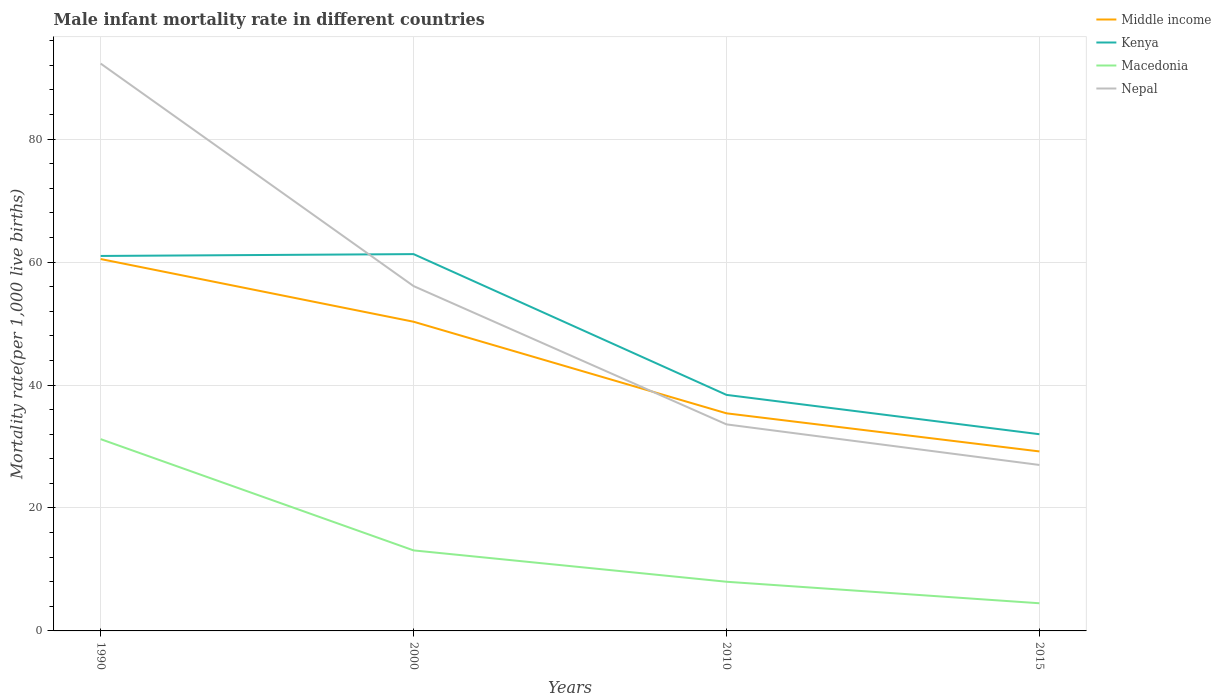In which year was the male infant mortality rate in Middle income maximum?
Provide a short and direct response. 2015. What is the total male infant mortality rate in Middle income in the graph?
Offer a very short reply. 10.2. What is the difference between the highest and the second highest male infant mortality rate in Middle income?
Your answer should be very brief. 31.3. What is the difference between the highest and the lowest male infant mortality rate in Nepal?
Your response must be concise. 2. Is the male infant mortality rate in Kenya strictly greater than the male infant mortality rate in Middle income over the years?
Offer a very short reply. No. How many years are there in the graph?
Your answer should be compact. 4. Does the graph contain grids?
Keep it short and to the point. Yes. How many legend labels are there?
Offer a very short reply. 4. What is the title of the graph?
Provide a succinct answer. Male infant mortality rate in different countries. Does "Barbados" appear as one of the legend labels in the graph?
Keep it short and to the point. No. What is the label or title of the Y-axis?
Offer a terse response. Mortality rate(per 1,0 live births). What is the Mortality rate(per 1,000 live births) of Middle income in 1990?
Make the answer very short. 60.5. What is the Mortality rate(per 1,000 live births) of Kenya in 1990?
Offer a very short reply. 61. What is the Mortality rate(per 1,000 live births) of Macedonia in 1990?
Offer a terse response. 31.2. What is the Mortality rate(per 1,000 live births) in Nepal in 1990?
Give a very brief answer. 92.3. What is the Mortality rate(per 1,000 live births) in Middle income in 2000?
Offer a terse response. 50.3. What is the Mortality rate(per 1,000 live births) in Kenya in 2000?
Provide a short and direct response. 61.3. What is the Mortality rate(per 1,000 live births) of Nepal in 2000?
Offer a very short reply. 56.1. What is the Mortality rate(per 1,000 live births) of Middle income in 2010?
Ensure brevity in your answer.  35.4. What is the Mortality rate(per 1,000 live births) in Kenya in 2010?
Offer a terse response. 38.4. What is the Mortality rate(per 1,000 live births) in Nepal in 2010?
Make the answer very short. 33.6. What is the Mortality rate(per 1,000 live births) in Middle income in 2015?
Offer a terse response. 29.2. What is the Mortality rate(per 1,000 live births) of Kenya in 2015?
Make the answer very short. 32. Across all years, what is the maximum Mortality rate(per 1,000 live births) in Middle income?
Ensure brevity in your answer.  60.5. Across all years, what is the maximum Mortality rate(per 1,000 live births) in Kenya?
Your answer should be very brief. 61.3. Across all years, what is the maximum Mortality rate(per 1,000 live births) of Macedonia?
Offer a very short reply. 31.2. Across all years, what is the maximum Mortality rate(per 1,000 live births) of Nepal?
Make the answer very short. 92.3. Across all years, what is the minimum Mortality rate(per 1,000 live births) of Middle income?
Provide a short and direct response. 29.2. Across all years, what is the minimum Mortality rate(per 1,000 live births) of Nepal?
Your answer should be very brief. 27. What is the total Mortality rate(per 1,000 live births) of Middle income in the graph?
Your answer should be very brief. 175.4. What is the total Mortality rate(per 1,000 live births) of Kenya in the graph?
Your response must be concise. 192.7. What is the total Mortality rate(per 1,000 live births) in Macedonia in the graph?
Give a very brief answer. 56.8. What is the total Mortality rate(per 1,000 live births) in Nepal in the graph?
Offer a terse response. 209. What is the difference between the Mortality rate(per 1,000 live births) of Nepal in 1990 and that in 2000?
Ensure brevity in your answer.  36.2. What is the difference between the Mortality rate(per 1,000 live births) of Middle income in 1990 and that in 2010?
Ensure brevity in your answer.  25.1. What is the difference between the Mortality rate(per 1,000 live births) of Kenya in 1990 and that in 2010?
Your answer should be compact. 22.6. What is the difference between the Mortality rate(per 1,000 live births) in Macedonia in 1990 and that in 2010?
Offer a terse response. 23.2. What is the difference between the Mortality rate(per 1,000 live births) in Nepal in 1990 and that in 2010?
Ensure brevity in your answer.  58.7. What is the difference between the Mortality rate(per 1,000 live births) in Middle income in 1990 and that in 2015?
Offer a terse response. 31.3. What is the difference between the Mortality rate(per 1,000 live births) in Kenya in 1990 and that in 2015?
Offer a very short reply. 29. What is the difference between the Mortality rate(per 1,000 live births) in Macedonia in 1990 and that in 2015?
Offer a very short reply. 26.7. What is the difference between the Mortality rate(per 1,000 live births) in Nepal in 1990 and that in 2015?
Provide a succinct answer. 65.3. What is the difference between the Mortality rate(per 1,000 live births) in Kenya in 2000 and that in 2010?
Offer a very short reply. 22.9. What is the difference between the Mortality rate(per 1,000 live births) in Middle income in 2000 and that in 2015?
Keep it short and to the point. 21.1. What is the difference between the Mortality rate(per 1,000 live births) of Kenya in 2000 and that in 2015?
Ensure brevity in your answer.  29.3. What is the difference between the Mortality rate(per 1,000 live births) of Nepal in 2000 and that in 2015?
Ensure brevity in your answer.  29.1. What is the difference between the Mortality rate(per 1,000 live births) in Macedonia in 2010 and that in 2015?
Offer a very short reply. 3.5. What is the difference between the Mortality rate(per 1,000 live births) of Nepal in 2010 and that in 2015?
Your answer should be compact. 6.6. What is the difference between the Mortality rate(per 1,000 live births) of Middle income in 1990 and the Mortality rate(per 1,000 live births) of Macedonia in 2000?
Provide a short and direct response. 47.4. What is the difference between the Mortality rate(per 1,000 live births) of Kenya in 1990 and the Mortality rate(per 1,000 live births) of Macedonia in 2000?
Provide a short and direct response. 47.9. What is the difference between the Mortality rate(per 1,000 live births) in Macedonia in 1990 and the Mortality rate(per 1,000 live births) in Nepal in 2000?
Ensure brevity in your answer.  -24.9. What is the difference between the Mortality rate(per 1,000 live births) in Middle income in 1990 and the Mortality rate(per 1,000 live births) in Kenya in 2010?
Keep it short and to the point. 22.1. What is the difference between the Mortality rate(per 1,000 live births) in Middle income in 1990 and the Mortality rate(per 1,000 live births) in Macedonia in 2010?
Provide a short and direct response. 52.5. What is the difference between the Mortality rate(per 1,000 live births) of Middle income in 1990 and the Mortality rate(per 1,000 live births) of Nepal in 2010?
Your answer should be very brief. 26.9. What is the difference between the Mortality rate(per 1,000 live births) of Kenya in 1990 and the Mortality rate(per 1,000 live births) of Nepal in 2010?
Offer a terse response. 27.4. What is the difference between the Mortality rate(per 1,000 live births) of Middle income in 1990 and the Mortality rate(per 1,000 live births) of Nepal in 2015?
Ensure brevity in your answer.  33.5. What is the difference between the Mortality rate(per 1,000 live births) of Kenya in 1990 and the Mortality rate(per 1,000 live births) of Macedonia in 2015?
Provide a short and direct response. 56.5. What is the difference between the Mortality rate(per 1,000 live births) in Kenya in 1990 and the Mortality rate(per 1,000 live births) in Nepal in 2015?
Provide a succinct answer. 34. What is the difference between the Mortality rate(per 1,000 live births) of Middle income in 2000 and the Mortality rate(per 1,000 live births) of Kenya in 2010?
Keep it short and to the point. 11.9. What is the difference between the Mortality rate(per 1,000 live births) in Middle income in 2000 and the Mortality rate(per 1,000 live births) in Macedonia in 2010?
Offer a terse response. 42.3. What is the difference between the Mortality rate(per 1,000 live births) of Middle income in 2000 and the Mortality rate(per 1,000 live births) of Nepal in 2010?
Give a very brief answer. 16.7. What is the difference between the Mortality rate(per 1,000 live births) of Kenya in 2000 and the Mortality rate(per 1,000 live births) of Macedonia in 2010?
Your answer should be very brief. 53.3. What is the difference between the Mortality rate(per 1,000 live births) of Kenya in 2000 and the Mortality rate(per 1,000 live births) of Nepal in 2010?
Make the answer very short. 27.7. What is the difference between the Mortality rate(per 1,000 live births) of Macedonia in 2000 and the Mortality rate(per 1,000 live births) of Nepal in 2010?
Your answer should be very brief. -20.5. What is the difference between the Mortality rate(per 1,000 live births) of Middle income in 2000 and the Mortality rate(per 1,000 live births) of Kenya in 2015?
Your answer should be compact. 18.3. What is the difference between the Mortality rate(per 1,000 live births) in Middle income in 2000 and the Mortality rate(per 1,000 live births) in Macedonia in 2015?
Give a very brief answer. 45.8. What is the difference between the Mortality rate(per 1,000 live births) in Middle income in 2000 and the Mortality rate(per 1,000 live births) in Nepal in 2015?
Make the answer very short. 23.3. What is the difference between the Mortality rate(per 1,000 live births) of Kenya in 2000 and the Mortality rate(per 1,000 live births) of Macedonia in 2015?
Offer a very short reply. 56.8. What is the difference between the Mortality rate(per 1,000 live births) in Kenya in 2000 and the Mortality rate(per 1,000 live births) in Nepal in 2015?
Keep it short and to the point. 34.3. What is the difference between the Mortality rate(per 1,000 live births) in Macedonia in 2000 and the Mortality rate(per 1,000 live births) in Nepal in 2015?
Your answer should be compact. -13.9. What is the difference between the Mortality rate(per 1,000 live births) of Middle income in 2010 and the Mortality rate(per 1,000 live births) of Macedonia in 2015?
Provide a short and direct response. 30.9. What is the difference between the Mortality rate(per 1,000 live births) of Middle income in 2010 and the Mortality rate(per 1,000 live births) of Nepal in 2015?
Give a very brief answer. 8.4. What is the difference between the Mortality rate(per 1,000 live births) of Kenya in 2010 and the Mortality rate(per 1,000 live births) of Macedonia in 2015?
Keep it short and to the point. 33.9. What is the difference between the Mortality rate(per 1,000 live births) in Kenya in 2010 and the Mortality rate(per 1,000 live births) in Nepal in 2015?
Provide a succinct answer. 11.4. What is the difference between the Mortality rate(per 1,000 live births) of Macedonia in 2010 and the Mortality rate(per 1,000 live births) of Nepal in 2015?
Provide a short and direct response. -19. What is the average Mortality rate(per 1,000 live births) in Middle income per year?
Your answer should be very brief. 43.85. What is the average Mortality rate(per 1,000 live births) in Kenya per year?
Keep it short and to the point. 48.17. What is the average Mortality rate(per 1,000 live births) in Macedonia per year?
Make the answer very short. 14.2. What is the average Mortality rate(per 1,000 live births) in Nepal per year?
Make the answer very short. 52.25. In the year 1990, what is the difference between the Mortality rate(per 1,000 live births) of Middle income and Mortality rate(per 1,000 live births) of Macedonia?
Offer a very short reply. 29.3. In the year 1990, what is the difference between the Mortality rate(per 1,000 live births) of Middle income and Mortality rate(per 1,000 live births) of Nepal?
Your answer should be very brief. -31.8. In the year 1990, what is the difference between the Mortality rate(per 1,000 live births) of Kenya and Mortality rate(per 1,000 live births) of Macedonia?
Provide a succinct answer. 29.8. In the year 1990, what is the difference between the Mortality rate(per 1,000 live births) of Kenya and Mortality rate(per 1,000 live births) of Nepal?
Provide a succinct answer. -31.3. In the year 1990, what is the difference between the Mortality rate(per 1,000 live births) of Macedonia and Mortality rate(per 1,000 live births) of Nepal?
Your response must be concise. -61.1. In the year 2000, what is the difference between the Mortality rate(per 1,000 live births) of Middle income and Mortality rate(per 1,000 live births) of Kenya?
Offer a terse response. -11. In the year 2000, what is the difference between the Mortality rate(per 1,000 live births) of Middle income and Mortality rate(per 1,000 live births) of Macedonia?
Ensure brevity in your answer.  37.2. In the year 2000, what is the difference between the Mortality rate(per 1,000 live births) in Middle income and Mortality rate(per 1,000 live births) in Nepal?
Give a very brief answer. -5.8. In the year 2000, what is the difference between the Mortality rate(per 1,000 live births) of Kenya and Mortality rate(per 1,000 live births) of Macedonia?
Provide a succinct answer. 48.2. In the year 2000, what is the difference between the Mortality rate(per 1,000 live births) in Kenya and Mortality rate(per 1,000 live births) in Nepal?
Offer a very short reply. 5.2. In the year 2000, what is the difference between the Mortality rate(per 1,000 live births) in Macedonia and Mortality rate(per 1,000 live births) in Nepal?
Offer a very short reply. -43. In the year 2010, what is the difference between the Mortality rate(per 1,000 live births) of Middle income and Mortality rate(per 1,000 live births) of Kenya?
Your answer should be compact. -3. In the year 2010, what is the difference between the Mortality rate(per 1,000 live births) of Middle income and Mortality rate(per 1,000 live births) of Macedonia?
Your response must be concise. 27.4. In the year 2010, what is the difference between the Mortality rate(per 1,000 live births) in Middle income and Mortality rate(per 1,000 live births) in Nepal?
Provide a short and direct response. 1.8. In the year 2010, what is the difference between the Mortality rate(per 1,000 live births) in Kenya and Mortality rate(per 1,000 live births) in Macedonia?
Your response must be concise. 30.4. In the year 2010, what is the difference between the Mortality rate(per 1,000 live births) in Macedonia and Mortality rate(per 1,000 live births) in Nepal?
Ensure brevity in your answer.  -25.6. In the year 2015, what is the difference between the Mortality rate(per 1,000 live births) in Middle income and Mortality rate(per 1,000 live births) in Kenya?
Give a very brief answer. -2.8. In the year 2015, what is the difference between the Mortality rate(per 1,000 live births) of Middle income and Mortality rate(per 1,000 live births) of Macedonia?
Your answer should be very brief. 24.7. In the year 2015, what is the difference between the Mortality rate(per 1,000 live births) in Middle income and Mortality rate(per 1,000 live births) in Nepal?
Give a very brief answer. 2.2. In the year 2015, what is the difference between the Mortality rate(per 1,000 live births) of Kenya and Mortality rate(per 1,000 live births) of Macedonia?
Offer a very short reply. 27.5. In the year 2015, what is the difference between the Mortality rate(per 1,000 live births) in Macedonia and Mortality rate(per 1,000 live births) in Nepal?
Provide a short and direct response. -22.5. What is the ratio of the Mortality rate(per 1,000 live births) of Middle income in 1990 to that in 2000?
Give a very brief answer. 1.2. What is the ratio of the Mortality rate(per 1,000 live births) in Macedonia in 1990 to that in 2000?
Keep it short and to the point. 2.38. What is the ratio of the Mortality rate(per 1,000 live births) of Nepal in 1990 to that in 2000?
Offer a terse response. 1.65. What is the ratio of the Mortality rate(per 1,000 live births) of Middle income in 1990 to that in 2010?
Offer a terse response. 1.71. What is the ratio of the Mortality rate(per 1,000 live births) of Kenya in 1990 to that in 2010?
Your answer should be very brief. 1.59. What is the ratio of the Mortality rate(per 1,000 live births) of Macedonia in 1990 to that in 2010?
Provide a succinct answer. 3.9. What is the ratio of the Mortality rate(per 1,000 live births) of Nepal in 1990 to that in 2010?
Your answer should be compact. 2.75. What is the ratio of the Mortality rate(per 1,000 live births) in Middle income in 1990 to that in 2015?
Provide a short and direct response. 2.07. What is the ratio of the Mortality rate(per 1,000 live births) of Kenya in 1990 to that in 2015?
Your answer should be very brief. 1.91. What is the ratio of the Mortality rate(per 1,000 live births) in Macedonia in 1990 to that in 2015?
Keep it short and to the point. 6.93. What is the ratio of the Mortality rate(per 1,000 live births) of Nepal in 1990 to that in 2015?
Offer a very short reply. 3.42. What is the ratio of the Mortality rate(per 1,000 live births) in Middle income in 2000 to that in 2010?
Provide a short and direct response. 1.42. What is the ratio of the Mortality rate(per 1,000 live births) of Kenya in 2000 to that in 2010?
Give a very brief answer. 1.6. What is the ratio of the Mortality rate(per 1,000 live births) of Macedonia in 2000 to that in 2010?
Offer a terse response. 1.64. What is the ratio of the Mortality rate(per 1,000 live births) in Nepal in 2000 to that in 2010?
Give a very brief answer. 1.67. What is the ratio of the Mortality rate(per 1,000 live births) in Middle income in 2000 to that in 2015?
Provide a succinct answer. 1.72. What is the ratio of the Mortality rate(per 1,000 live births) in Kenya in 2000 to that in 2015?
Make the answer very short. 1.92. What is the ratio of the Mortality rate(per 1,000 live births) of Macedonia in 2000 to that in 2015?
Your response must be concise. 2.91. What is the ratio of the Mortality rate(per 1,000 live births) in Nepal in 2000 to that in 2015?
Give a very brief answer. 2.08. What is the ratio of the Mortality rate(per 1,000 live births) in Middle income in 2010 to that in 2015?
Your answer should be compact. 1.21. What is the ratio of the Mortality rate(per 1,000 live births) in Kenya in 2010 to that in 2015?
Ensure brevity in your answer.  1.2. What is the ratio of the Mortality rate(per 1,000 live births) in Macedonia in 2010 to that in 2015?
Your answer should be compact. 1.78. What is the ratio of the Mortality rate(per 1,000 live births) of Nepal in 2010 to that in 2015?
Offer a terse response. 1.24. What is the difference between the highest and the second highest Mortality rate(per 1,000 live births) in Kenya?
Offer a very short reply. 0.3. What is the difference between the highest and the second highest Mortality rate(per 1,000 live births) of Nepal?
Your response must be concise. 36.2. What is the difference between the highest and the lowest Mortality rate(per 1,000 live births) of Middle income?
Provide a succinct answer. 31.3. What is the difference between the highest and the lowest Mortality rate(per 1,000 live births) of Kenya?
Provide a short and direct response. 29.3. What is the difference between the highest and the lowest Mortality rate(per 1,000 live births) of Macedonia?
Ensure brevity in your answer.  26.7. What is the difference between the highest and the lowest Mortality rate(per 1,000 live births) in Nepal?
Offer a very short reply. 65.3. 